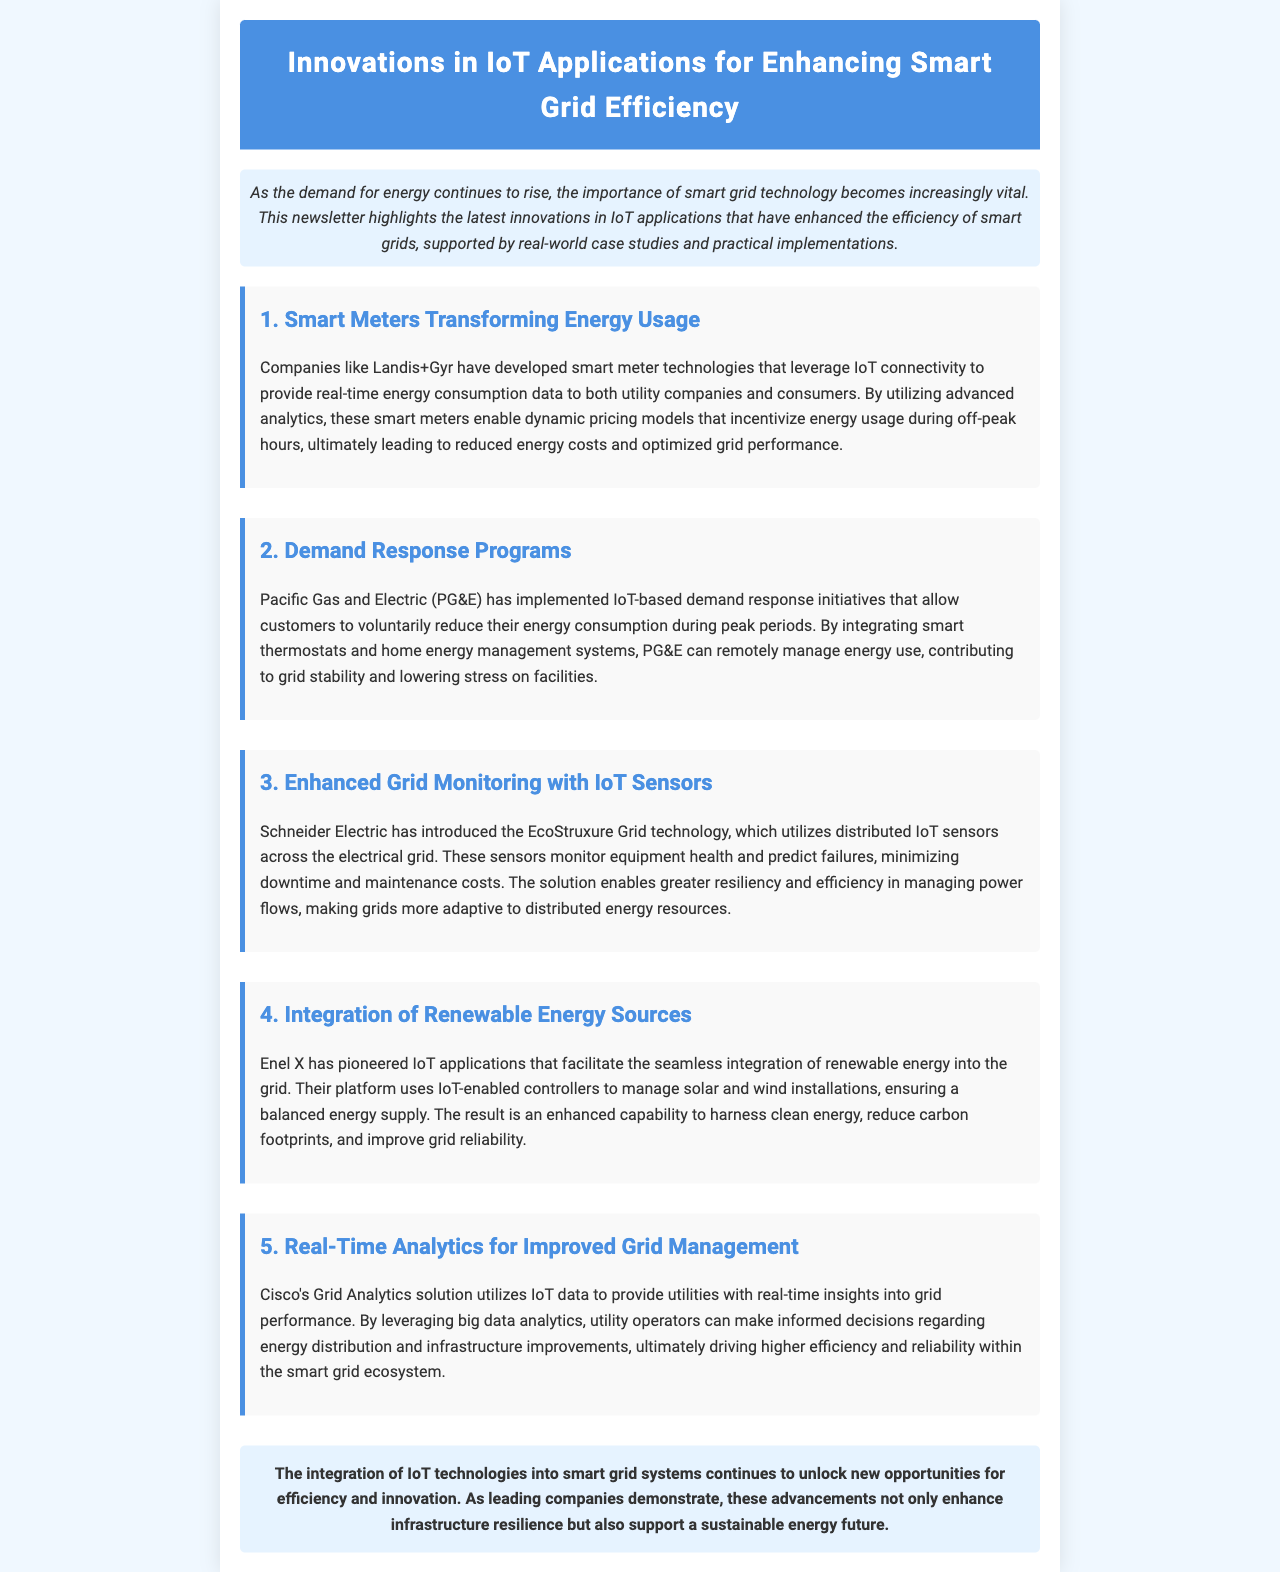what technology do Landis+Gyr develop? Landis+Gyr has developed smart meter technologies that leverage IoT connectivity.
Answer: smart meter technologies which company implemented demand response initiatives? Pacific Gas and Electric is the company mentioned that has implemented these initiatives.
Answer: Pacific Gas and Electric what technology does Schneider Electric use for grid monitoring? Schneider Electric uses EcoStruxure Grid technology for monitoring the electrical grid.
Answer: EcoStruxure Grid technology who pioneered IoT applications for renewable energy integration? Enel X is mentioned as the pioneer of IoT applications for renewable energy integration.
Answer: Enel X what does Cisco's Grid Analytics solution provide? Cisco's Grid Analytics solution provides real-time insights into grid performance.
Answer: real-time insights how do smart meters optimize grid performance? Smart meters enable dynamic pricing models that incentivize energy usage during off-peak hours.
Answer: dynamic pricing models which energy sources does Enel X's platform manage? Enel X's platform manages solar and wind installations for energy integration.
Answer: solar and wind what benefit do IoT sensors provide in grid management? IoT sensors monitor equipment health and predict failures, minimizing downtime.
Answer: predict failures how does PG&E contribute to grid stability? PG&E integrates smart thermostats and home energy management systems to manage energy use.
Answer: smart thermostats and management systems 